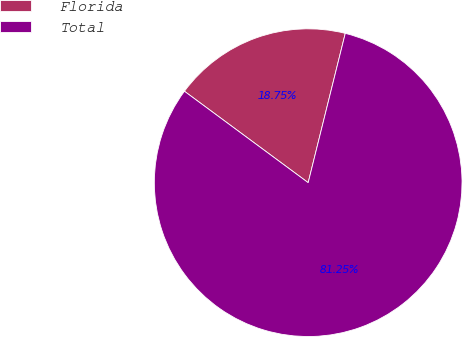Convert chart. <chart><loc_0><loc_0><loc_500><loc_500><pie_chart><fcel>Florida<fcel>Total<nl><fcel>18.75%<fcel>81.25%<nl></chart> 